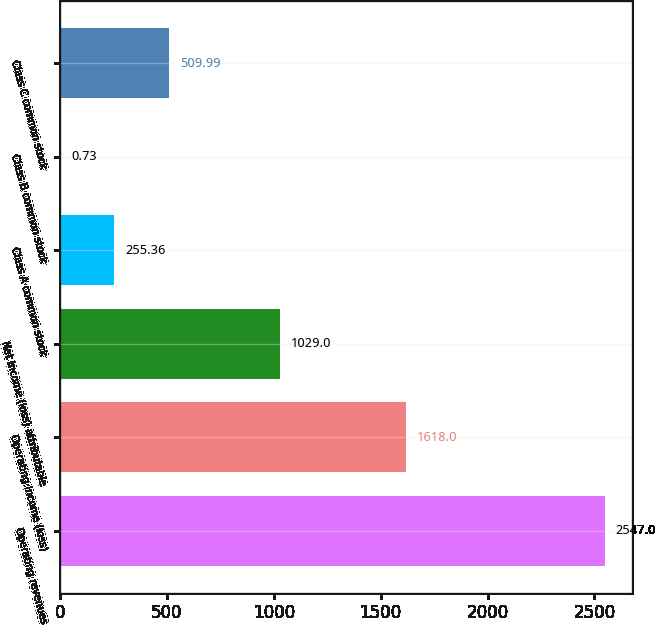Convert chart to OTSL. <chart><loc_0><loc_0><loc_500><loc_500><bar_chart><fcel>Operating revenues<fcel>Operating income (loss)<fcel>Net income (loss) attributable<fcel>Class A common stock<fcel>Class B common stock<fcel>Class C common stock<nl><fcel>2547<fcel>1618<fcel>1029<fcel>255.36<fcel>0.73<fcel>509.99<nl></chart> 